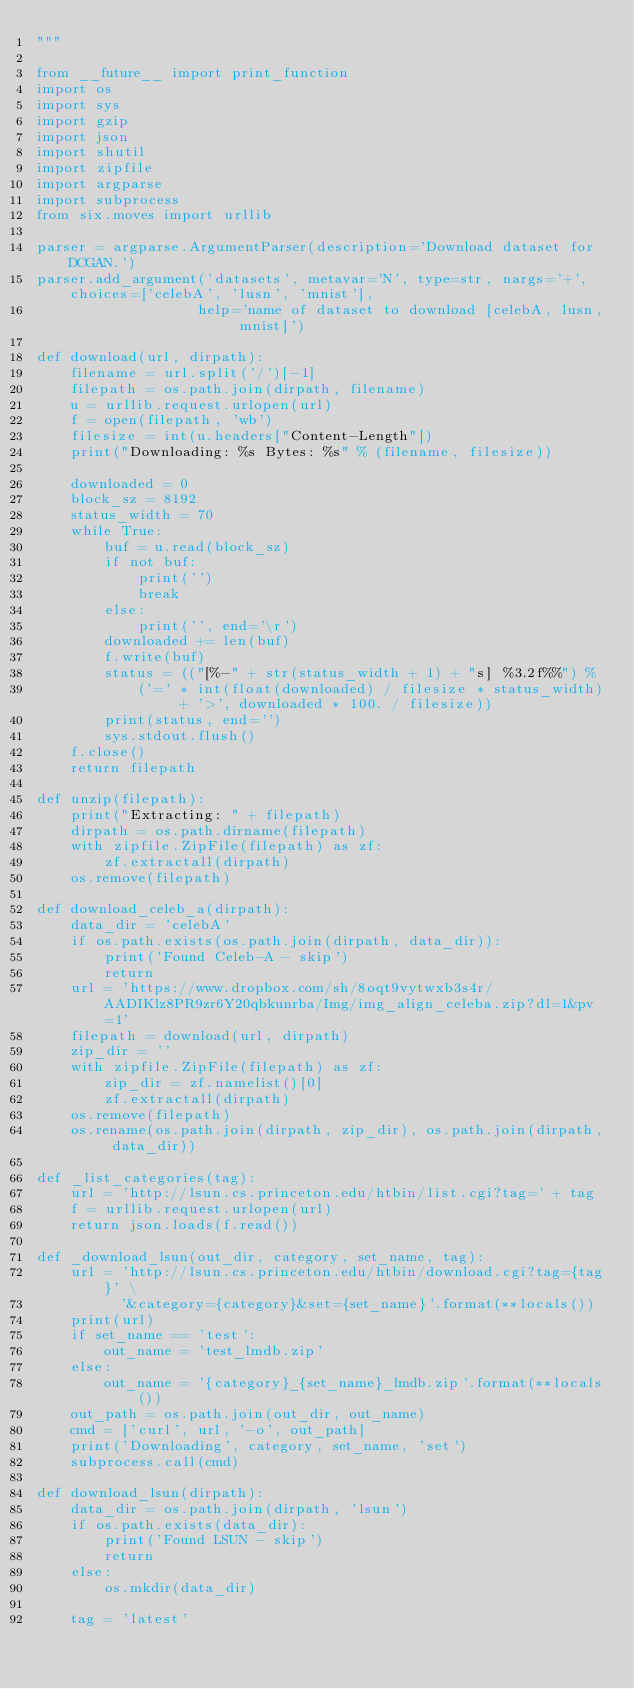<code> <loc_0><loc_0><loc_500><loc_500><_Python_>"""

from __future__ import print_function
import os
import sys
import gzip
import json
import shutil
import zipfile
import argparse
import subprocess
from six.moves import urllib

parser = argparse.ArgumentParser(description='Download dataset for DCGAN.')
parser.add_argument('datasets', metavar='N', type=str, nargs='+', choices=['celebA', 'lusn', 'mnist'],
                   help='name of dataset to download [celebA, lusn, mnist]')

def download(url, dirpath):
    filename = url.split('/')[-1]
    filepath = os.path.join(dirpath, filename)
    u = urllib.request.urlopen(url)
    f = open(filepath, 'wb')
    filesize = int(u.headers["Content-Length"])
    print("Downloading: %s Bytes: %s" % (filename, filesize))

    downloaded = 0
    block_sz = 8192
    status_width = 70
    while True:
        buf = u.read(block_sz)
        if not buf:
            print('')
            break
        else:
            print('', end='\r')
        downloaded += len(buf)
        f.write(buf)
        status = (("[%-" + str(status_width + 1) + "s] %3.2f%%") %
            ('=' * int(float(downloaded) / filesize * status_width) + '>', downloaded * 100. / filesize))
        print(status, end='')
        sys.stdout.flush()
    f.close()
    return filepath

def unzip(filepath):
    print("Extracting: " + filepath)
    dirpath = os.path.dirname(filepath)
    with zipfile.ZipFile(filepath) as zf:
        zf.extractall(dirpath)
    os.remove(filepath)

def download_celeb_a(dirpath):
    data_dir = 'celebA'
    if os.path.exists(os.path.join(dirpath, data_dir)):
        print('Found Celeb-A - skip')
        return
    url = 'https://www.dropbox.com/sh/8oqt9vytwxb3s4r/AADIKlz8PR9zr6Y20qbkunrba/Img/img_align_celeba.zip?dl=1&pv=1'
    filepath = download(url, dirpath)
    zip_dir = ''
    with zipfile.ZipFile(filepath) as zf:
        zip_dir = zf.namelist()[0]
        zf.extractall(dirpath)
    os.remove(filepath)
    os.rename(os.path.join(dirpath, zip_dir), os.path.join(dirpath, data_dir))

def _list_categories(tag):
    url = 'http://lsun.cs.princeton.edu/htbin/list.cgi?tag=' + tag
    f = urllib.request.urlopen(url)
    return json.loads(f.read())

def _download_lsun(out_dir, category, set_name, tag):
    url = 'http://lsun.cs.princeton.edu/htbin/download.cgi?tag={tag}' \
          '&category={category}&set={set_name}'.format(**locals())
    print(url)
    if set_name == 'test':
        out_name = 'test_lmdb.zip'
    else:
        out_name = '{category}_{set_name}_lmdb.zip'.format(**locals())
    out_path = os.path.join(out_dir, out_name)
    cmd = ['curl', url, '-o', out_path]
    print('Downloading', category, set_name, 'set')
    subprocess.call(cmd)

def download_lsun(dirpath):
    data_dir = os.path.join(dirpath, 'lsun')
    if os.path.exists(data_dir):
        print('Found LSUN - skip')
        return
    else:
        os.mkdir(data_dir)

    tag = 'latest'</code> 